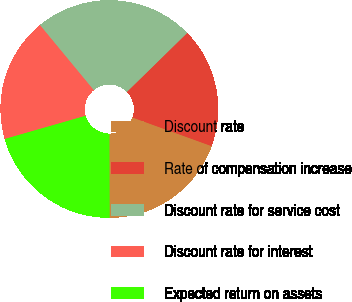<chart> <loc_0><loc_0><loc_500><loc_500><pie_chart><fcel>Discount rate<fcel>Rate of compensation increase<fcel>Discount rate for service cost<fcel>Discount rate for interest<fcel>Expected return on assets<nl><fcel>19.44%<fcel>17.85%<fcel>23.67%<fcel>18.45%<fcel>20.59%<nl></chart> 